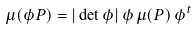Convert formula to latex. <formula><loc_0><loc_0><loc_500><loc_500>\mu ( \phi P ) = | \det \phi | \, \phi \, \mu ( P ) \, \phi ^ { t }</formula> 